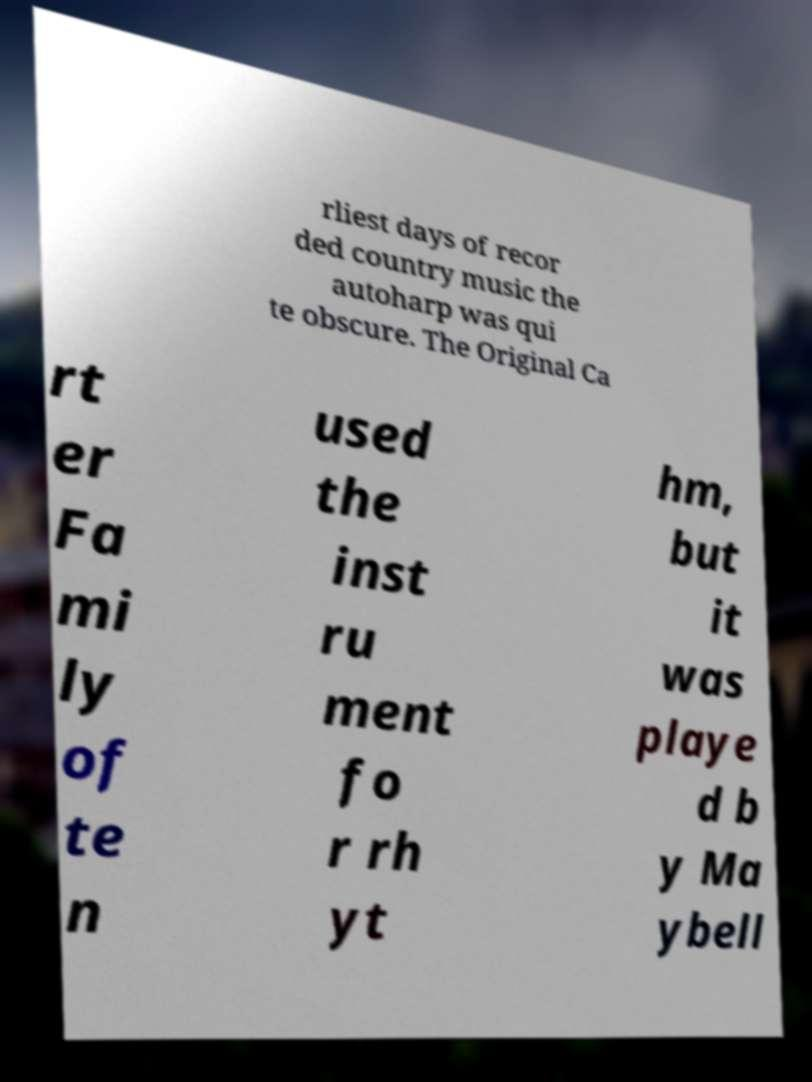I need the written content from this picture converted into text. Can you do that? rliest days of recor ded country music the autoharp was qui te obscure. The Original Ca rt er Fa mi ly of te n used the inst ru ment fo r rh yt hm, but it was playe d b y Ma ybell 